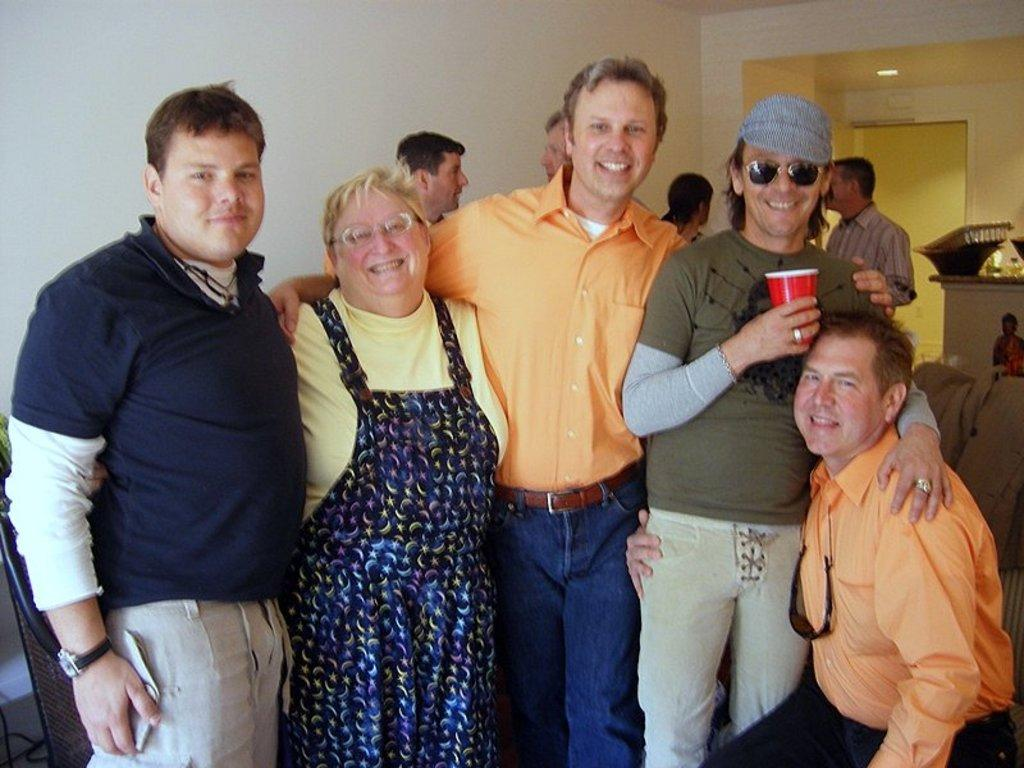What can be seen in the image? There are people standing in the image. What is visible in the background of the image? There is a wall in the background of the image. Can you identify any architectural features in the image? Yes, there is a door in the image. What type of fish can be seen swimming near the people in the image? There are no fish present in the image; it features people standing and a wall in the background. 